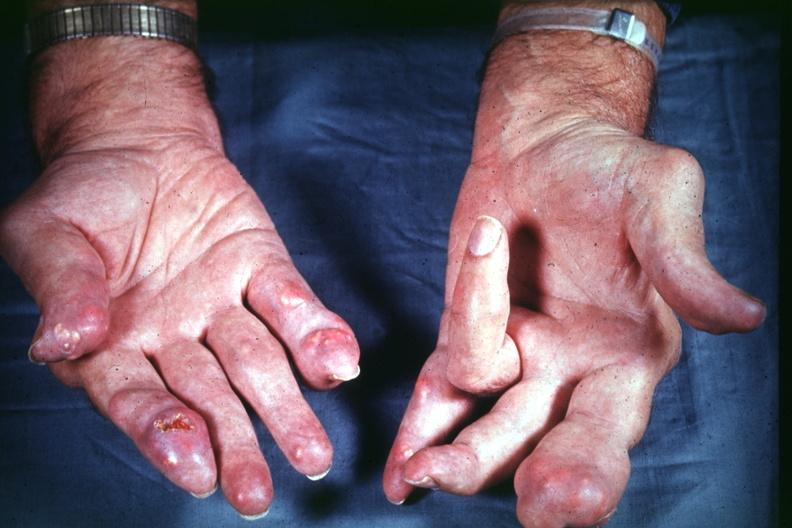what is present?
Answer the question using a single word or phrase. Hand 